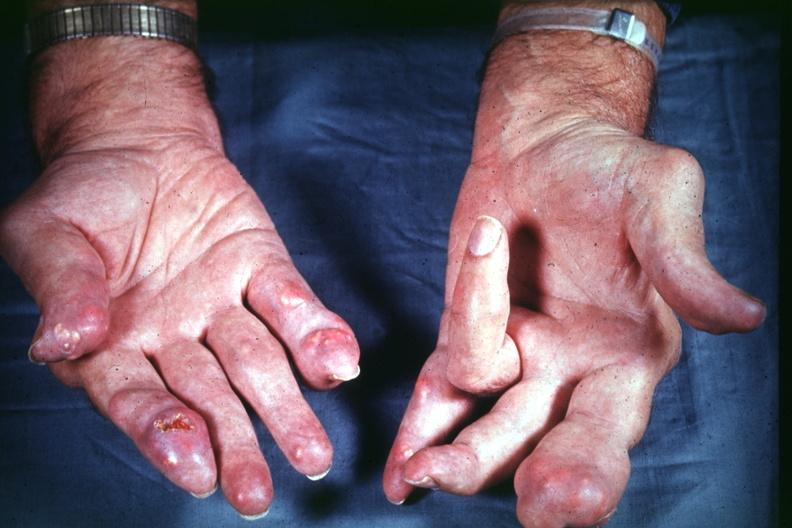what is present?
Answer the question using a single word or phrase. Hand 